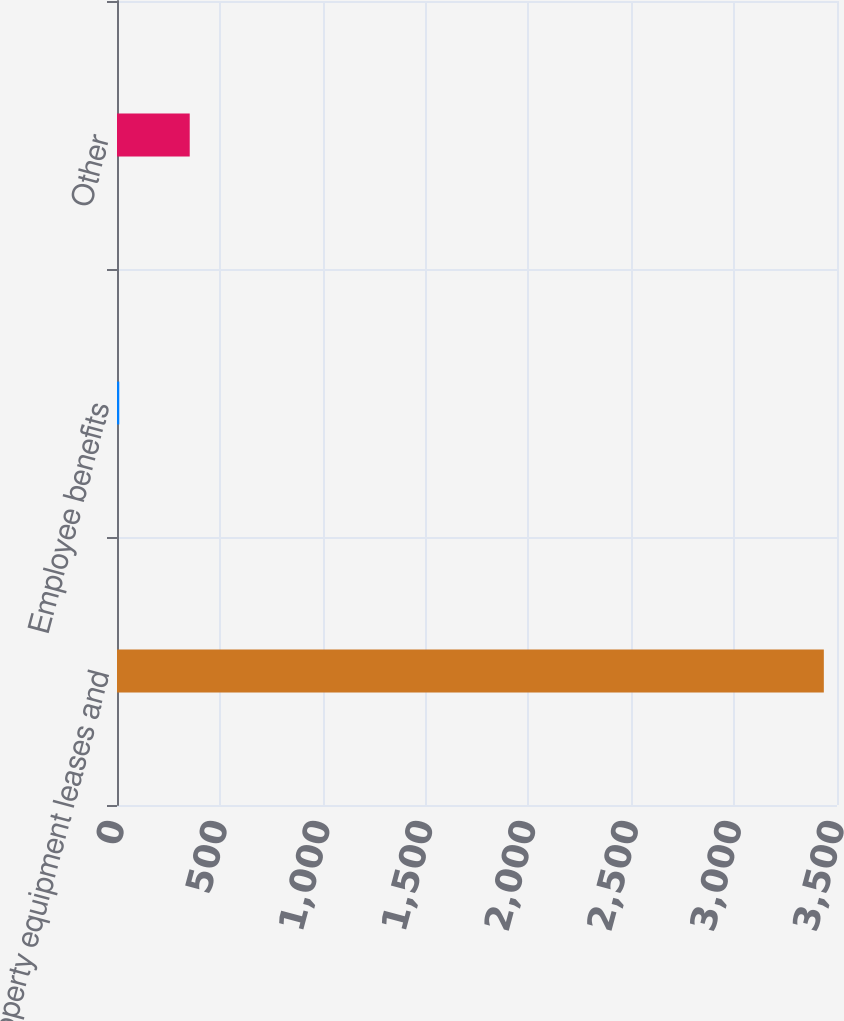Convert chart to OTSL. <chart><loc_0><loc_0><loc_500><loc_500><bar_chart><fcel>Property equipment leases and<fcel>Employee benefits<fcel>Other<nl><fcel>3436<fcel>11<fcel>353.5<nl></chart> 